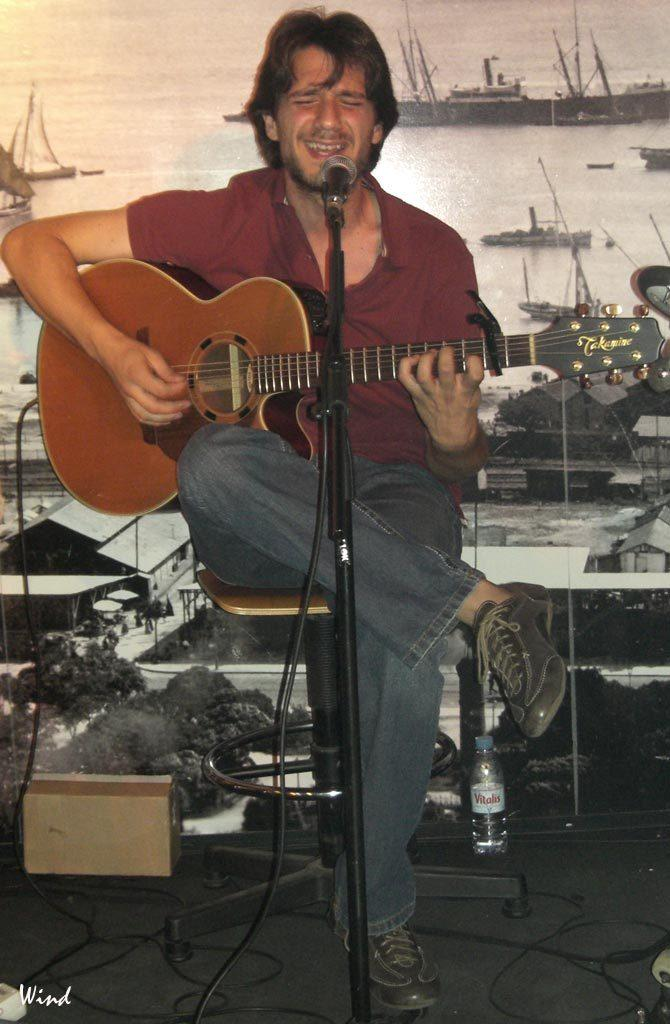What is the main subject of the image? There is a person in the image. What is the person doing in the image? The person is sitting on a chair, playing a guitar, and singing into a microphone. What type of lead is the person holding in the image? There is no lead present in the image; the person is holding a guitar and a microphone. 